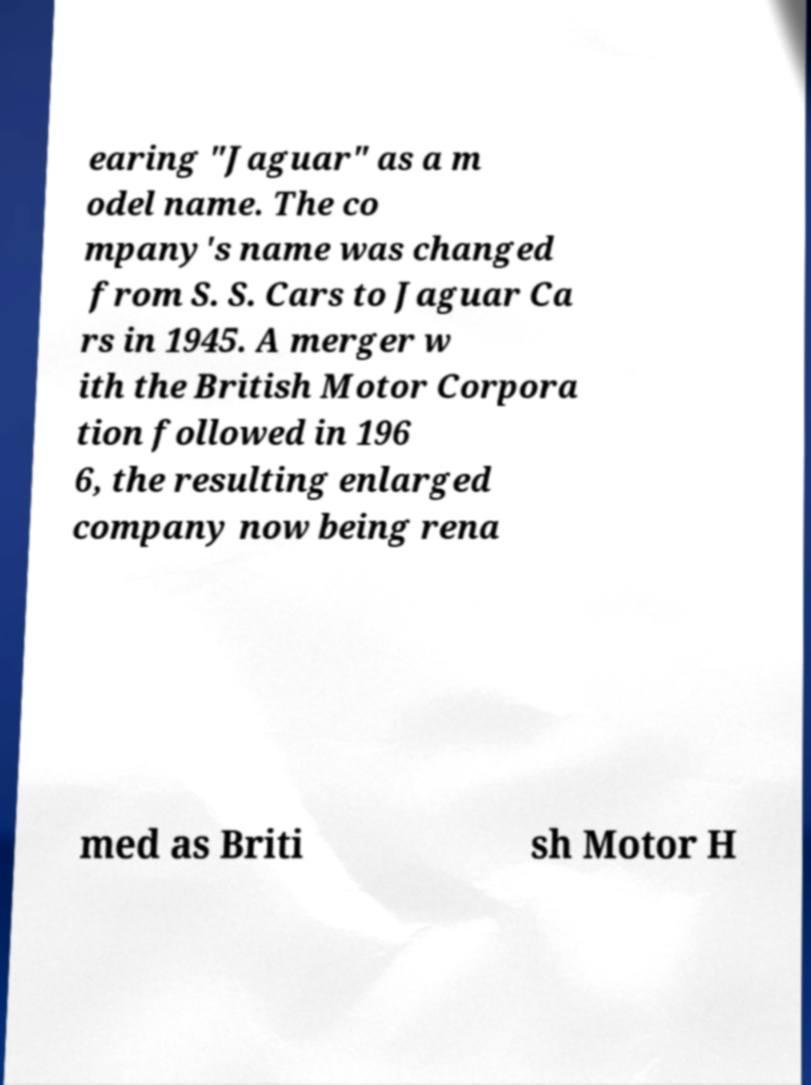Please read and relay the text visible in this image. What does it say? earing "Jaguar" as a m odel name. The co mpany's name was changed from S. S. Cars to Jaguar Ca rs in 1945. A merger w ith the British Motor Corpora tion followed in 196 6, the resulting enlarged company now being rena med as Briti sh Motor H 